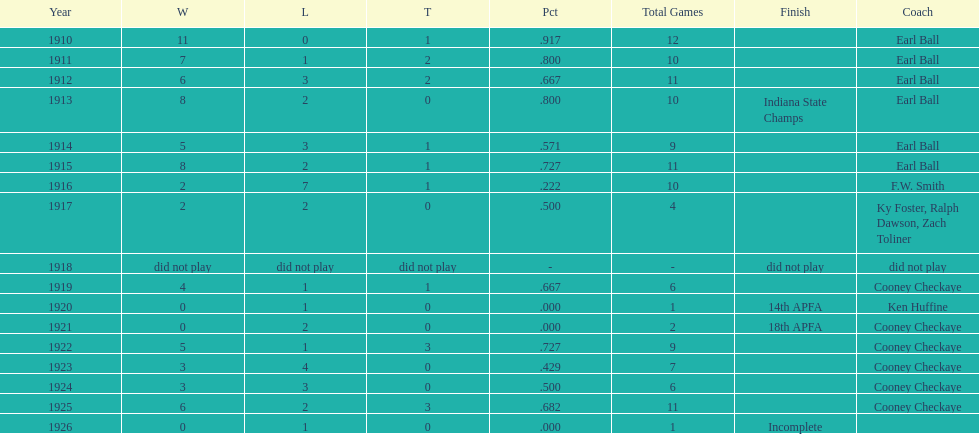The muncie flyers played from 1910 to 1925 in all but one of those years. which year did the flyers not play? 1918. 